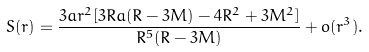Convert formula to latex. <formula><loc_0><loc_0><loc_500><loc_500>S ( r ) = \frac { 3 a r ^ { 2 } [ 3 R a ( R - 3 M ) - 4 R ^ { 2 } + 3 M ^ { 2 } ] } { R ^ { 5 } ( R - 3 M ) } + o ( r ^ { 3 } ) .</formula> 